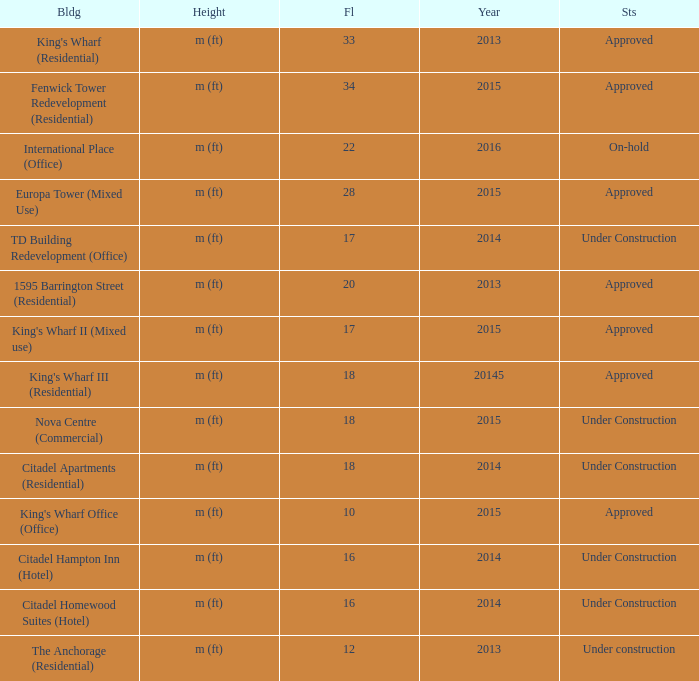What is the status of the building with less than 18 floors and later than 2013? Under Construction, Approved, Approved, Under Construction, Under Construction. 